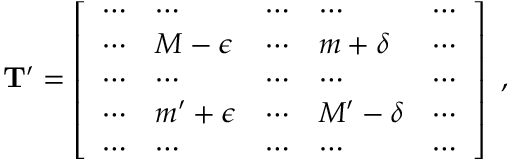Convert formula to latex. <formula><loc_0><loc_0><loc_500><loc_500>\begin{array} { r } { T ^ { \prime } = \left [ \begin{array} { l l l l l } { \cdots } & { \cdots } & { \cdots } & { \cdots } & { \cdots } \\ { \cdots } & { M - \epsilon } & { \cdots } & { m + \delta } & { \cdots } \\ { \cdots } & { \cdots } & { \cdots } & { \cdots } & { \cdots } \\ { \cdots } & { m ^ { \prime } + \epsilon } & { \cdots } & { M ^ { \prime } - \delta } & { \cdots } \\ { \cdots } & { \cdots } & { \cdots } & { \cdots } & { \cdots } \end{array} \right ] \, , } \end{array}</formula> 